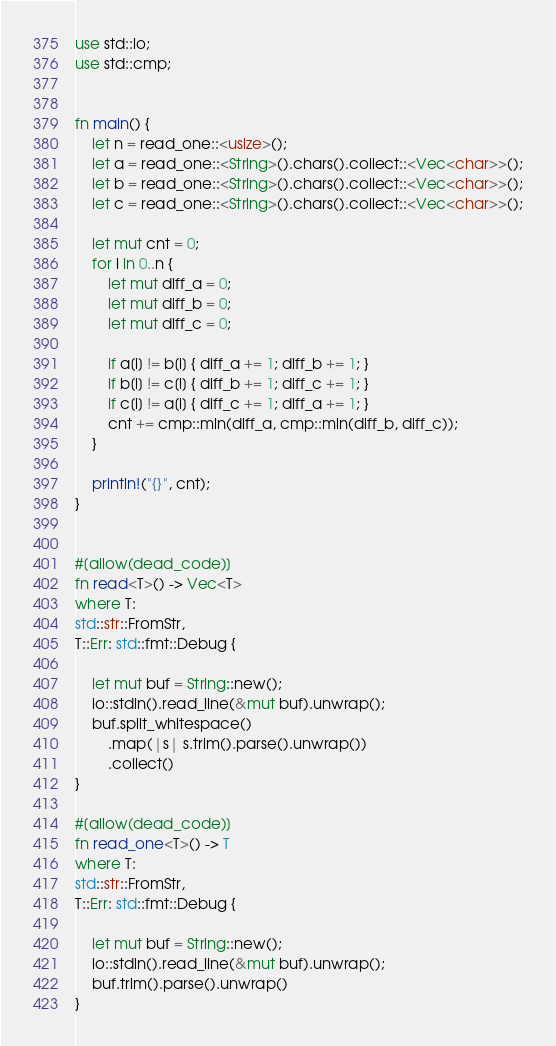Convert code to text. <code><loc_0><loc_0><loc_500><loc_500><_Rust_>use std::io;
use std::cmp;


fn main() {
    let n = read_one::<usize>();
    let a = read_one::<String>().chars().collect::<Vec<char>>();
    let b = read_one::<String>().chars().collect::<Vec<char>>();
    let c = read_one::<String>().chars().collect::<Vec<char>>();

    let mut cnt = 0;
    for i in 0..n {
        let mut diff_a = 0;
        let mut diff_b = 0;
        let mut diff_c = 0;

        if a[i] != b[i] { diff_a += 1; diff_b += 1; }
        if b[i] != c[i] { diff_b += 1; diff_c += 1; }
        if c[i] != a[i] { diff_c += 1; diff_a += 1; }
        cnt += cmp::min(diff_a, cmp::min(diff_b, diff_c));
    }

    println!("{}", cnt);
}


#[allow(dead_code)]
fn read<T>() -> Vec<T>
where T:
std::str::FromStr,
T::Err: std::fmt::Debug {

    let mut buf = String::new();
    io::stdin().read_line(&mut buf).unwrap();
    buf.split_whitespace()
        .map(|s| s.trim().parse().unwrap())
        .collect()
}

#[allow(dead_code)]
fn read_one<T>() -> T
where T:
std::str::FromStr,
T::Err: std::fmt::Debug {

    let mut buf = String::new();
    io::stdin().read_line(&mut buf).unwrap();
    buf.trim().parse().unwrap()
}</code> 